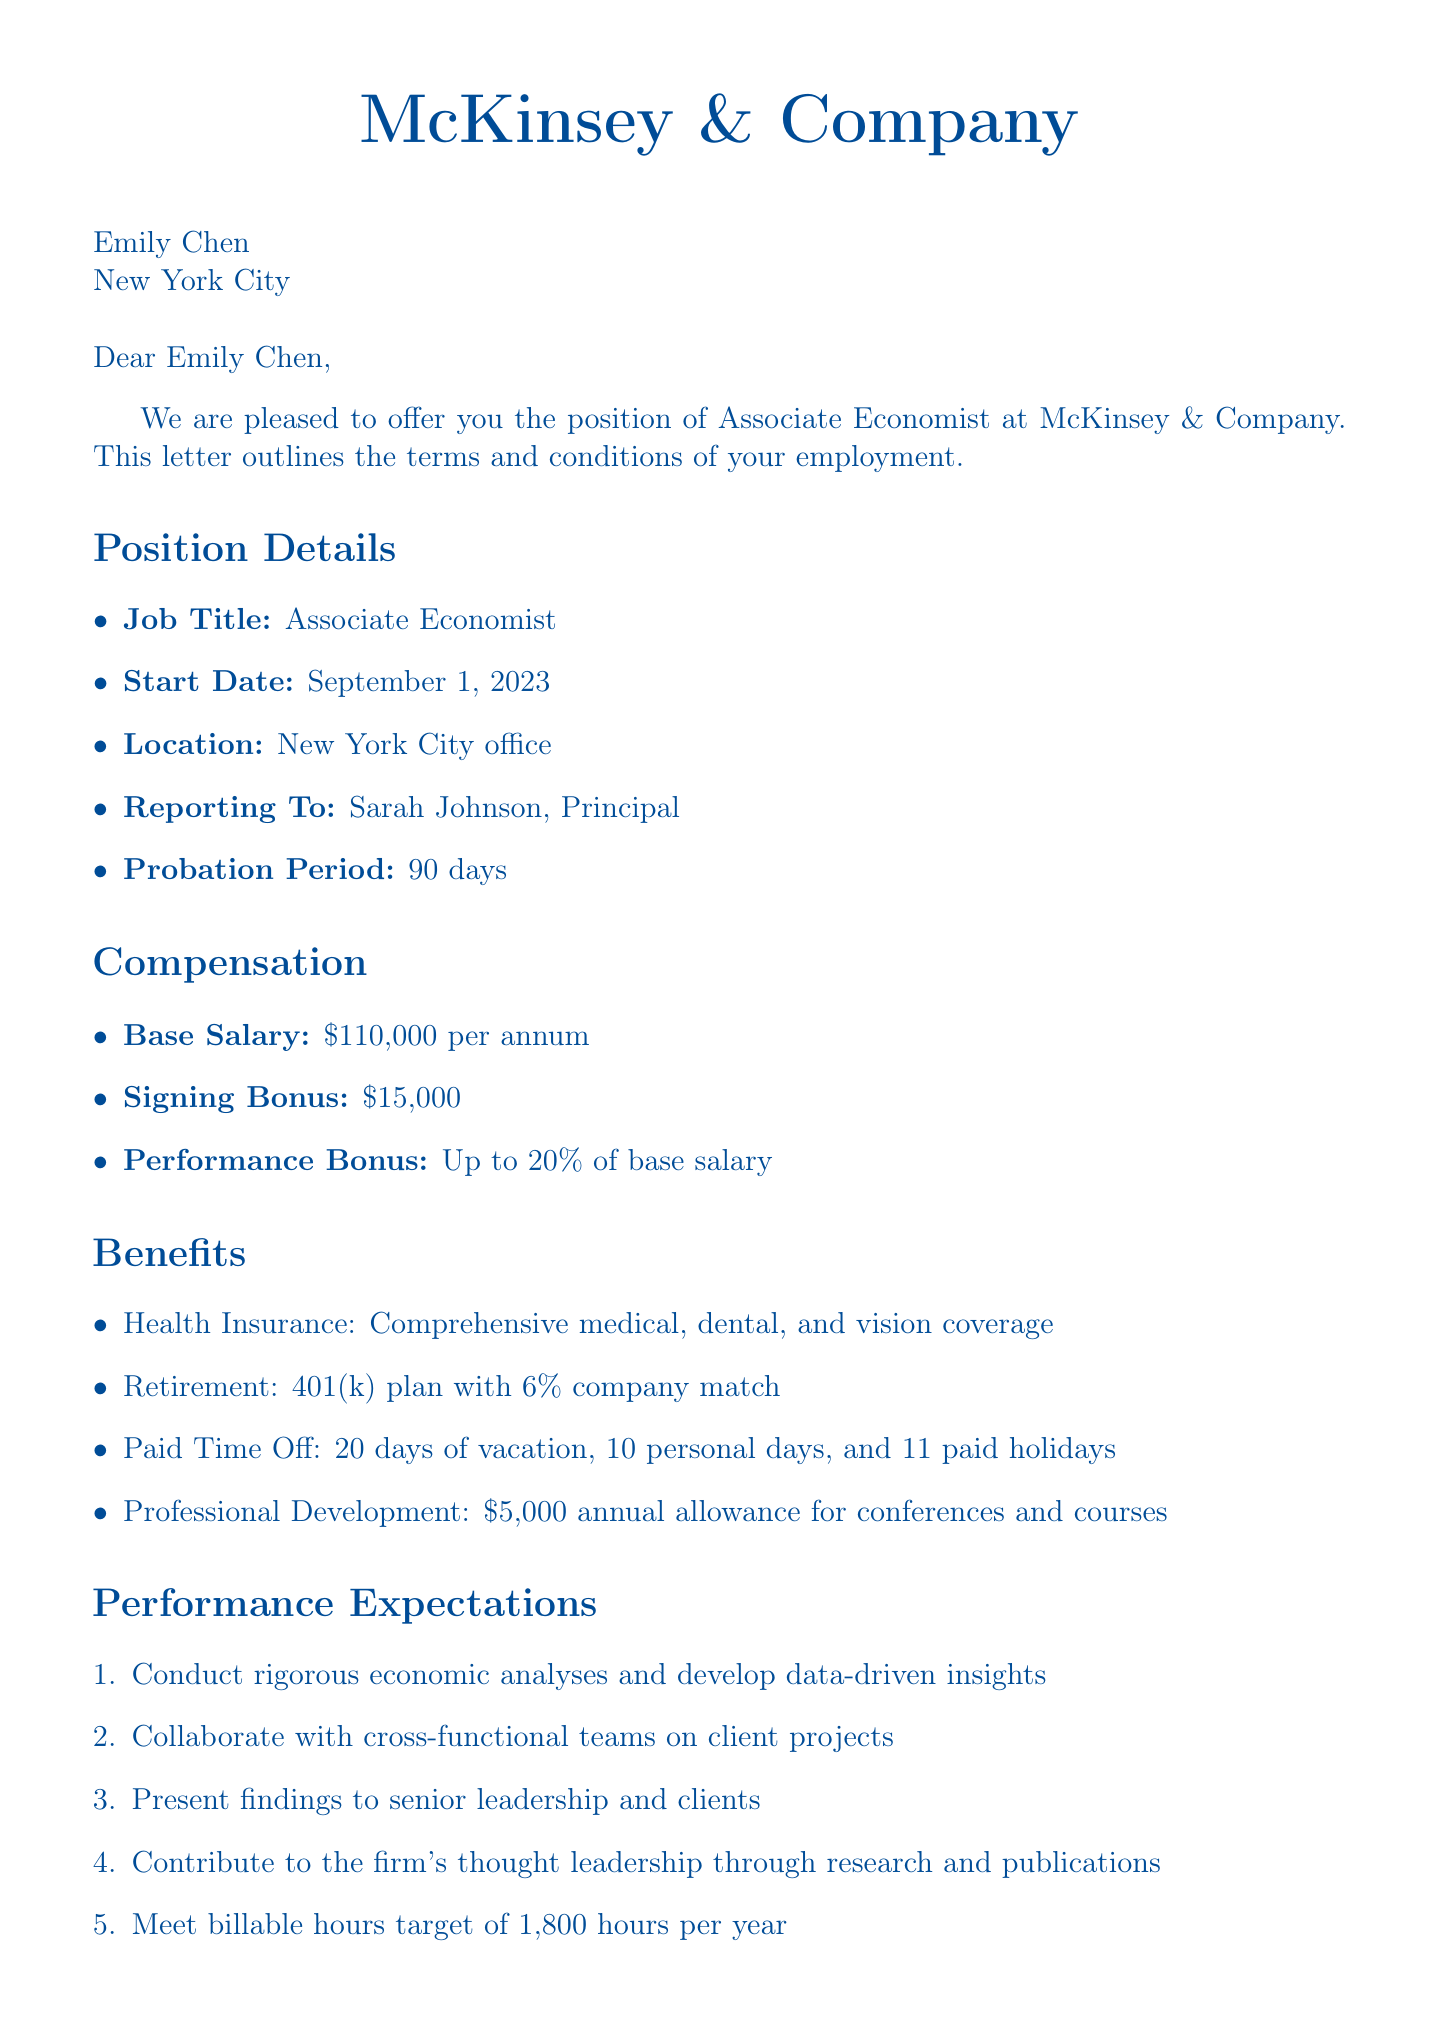What is the job title offered to Emily Chen? The document specifies that the position offered is for "Associate Economist."
Answer: Associate Economist What is the base salary for the position? The base salary is stated as $110,000 per annum.
Answer: $110,000 How much is the signing bonus? The signing bonus is explicitly mentioned as $15,000.
Answer: $15,000 What is the deadline for acceptance of the job offer? The document indicates that the acceptance deadline is two weeks from the date of the letter.
Answer: Two weeks What is the probation period duration? The document outlines the probation period as 90 days.
Answer: 90 days What is the target billable hours per year? The performance expectations section states the target billable hours to be 1,800 hours per year.
Answer: 1,800 hours What type of health insurance is offered? The benefits section describes the health insurance as "Comprehensive medical, dental, and vision coverage."
Answer: Comprehensive medical, dental, and vision coverage What is one of the growth opportunities mentioned? The document lists multiple growth opportunities, including fast-track to Senior Associate within 2-3 years based on performance.
Answer: Fast-track to Senior Associate within 2-3 years What is one performance metric related to project delivery? The document states that project delivery quality is measured by client satisfaction surveys.
Answer: Client satisfaction surveys 